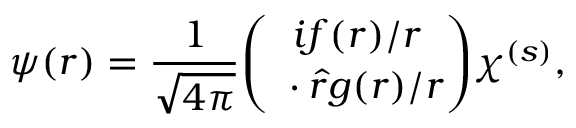Convert formula to latex. <formula><loc_0><loc_0><loc_500><loc_500>\psi ( r ) = { \frac { 1 } { \sqrt { 4 \pi } } } { \binom { i f ( r ) / r } { { \sigma } \cdot \hat { r } { g ( r ) / r } } } \chi ^ { ( s ) } ,</formula> 